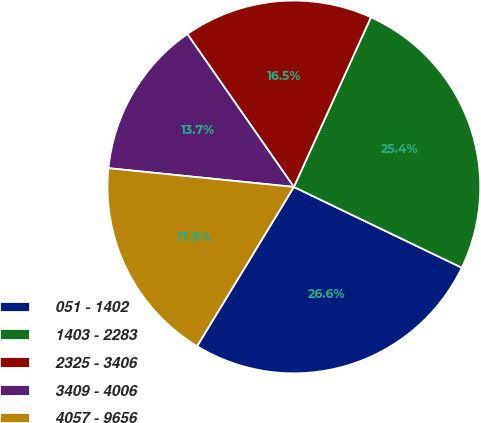Convert chart. <chart><loc_0><loc_0><loc_500><loc_500><pie_chart><fcel>051 - 1402<fcel>1403 - 2283<fcel>2325 - 3406<fcel>3409 - 4006<fcel>4057 - 9656<nl><fcel>26.56%<fcel>25.35%<fcel>16.47%<fcel>13.71%<fcel>17.91%<nl></chart> 